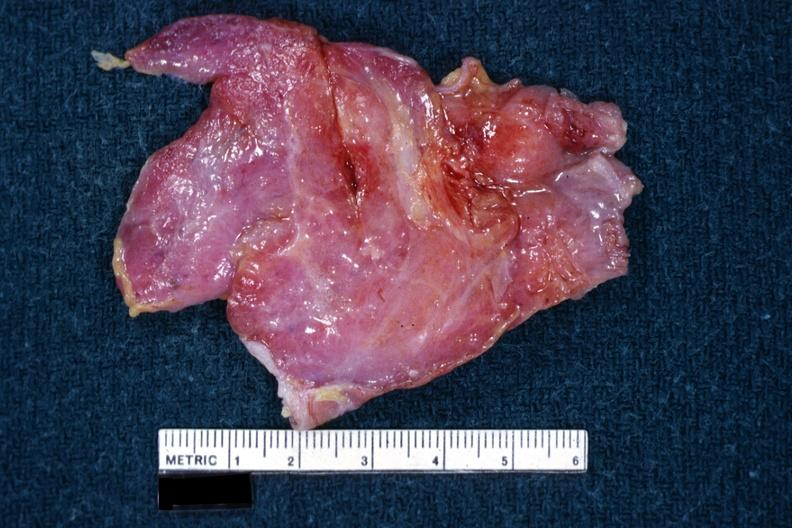what is a thymus?
Answer the question using a single word or phrase. This 